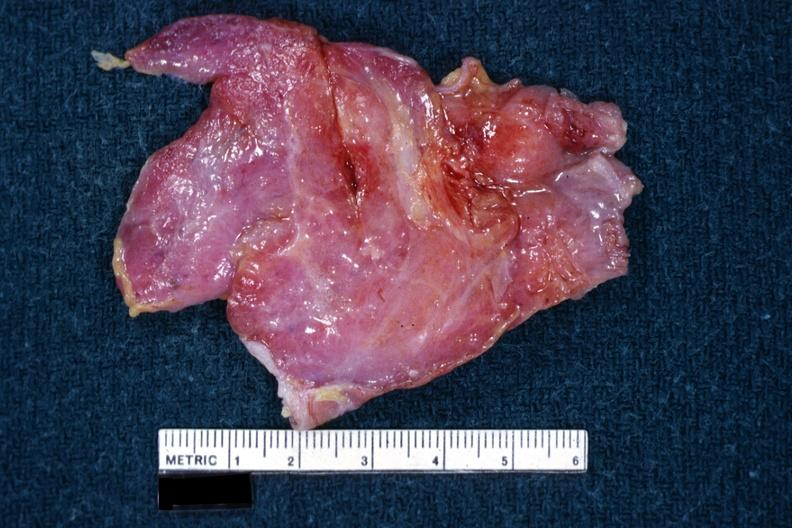what is a thymus?
Answer the question using a single word or phrase. This 